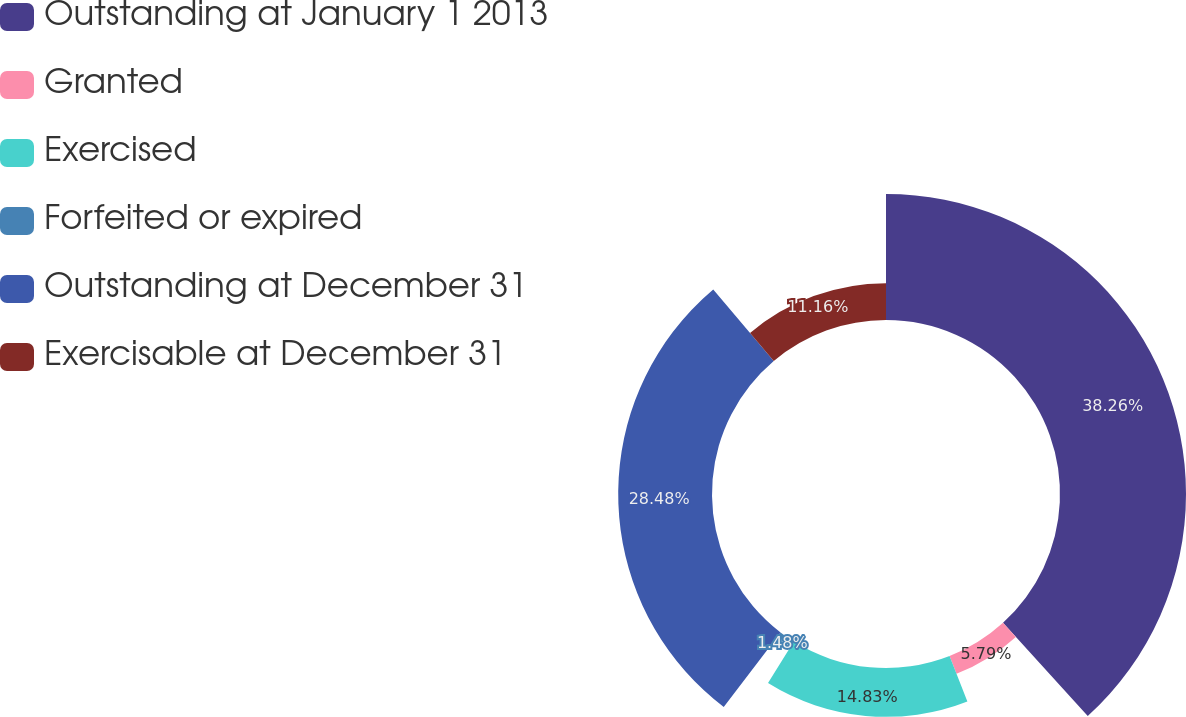Convert chart. <chart><loc_0><loc_0><loc_500><loc_500><pie_chart><fcel>Outstanding at January 1 2013<fcel>Granted<fcel>Exercised<fcel>Forfeited or expired<fcel>Outstanding at December 31<fcel>Exercisable at December 31<nl><fcel>38.26%<fcel>5.79%<fcel>14.83%<fcel>1.48%<fcel>28.48%<fcel>11.16%<nl></chart> 